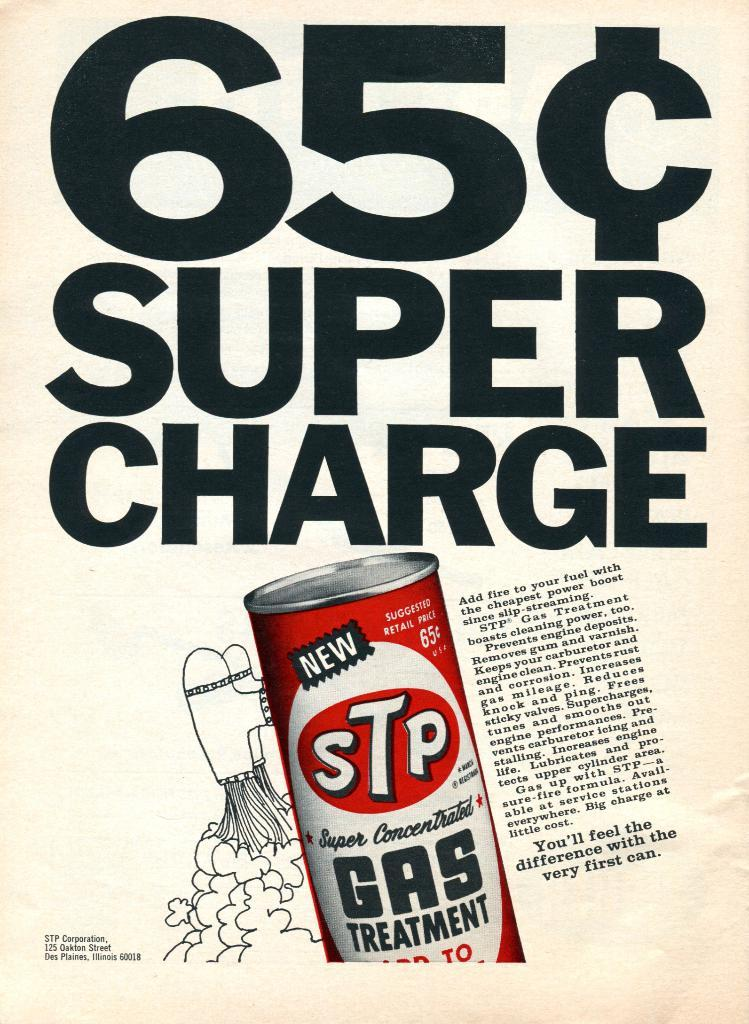<image>
Present a compact description of the photo's key features. An ad for a 65 cent super charge gas treatment product. 